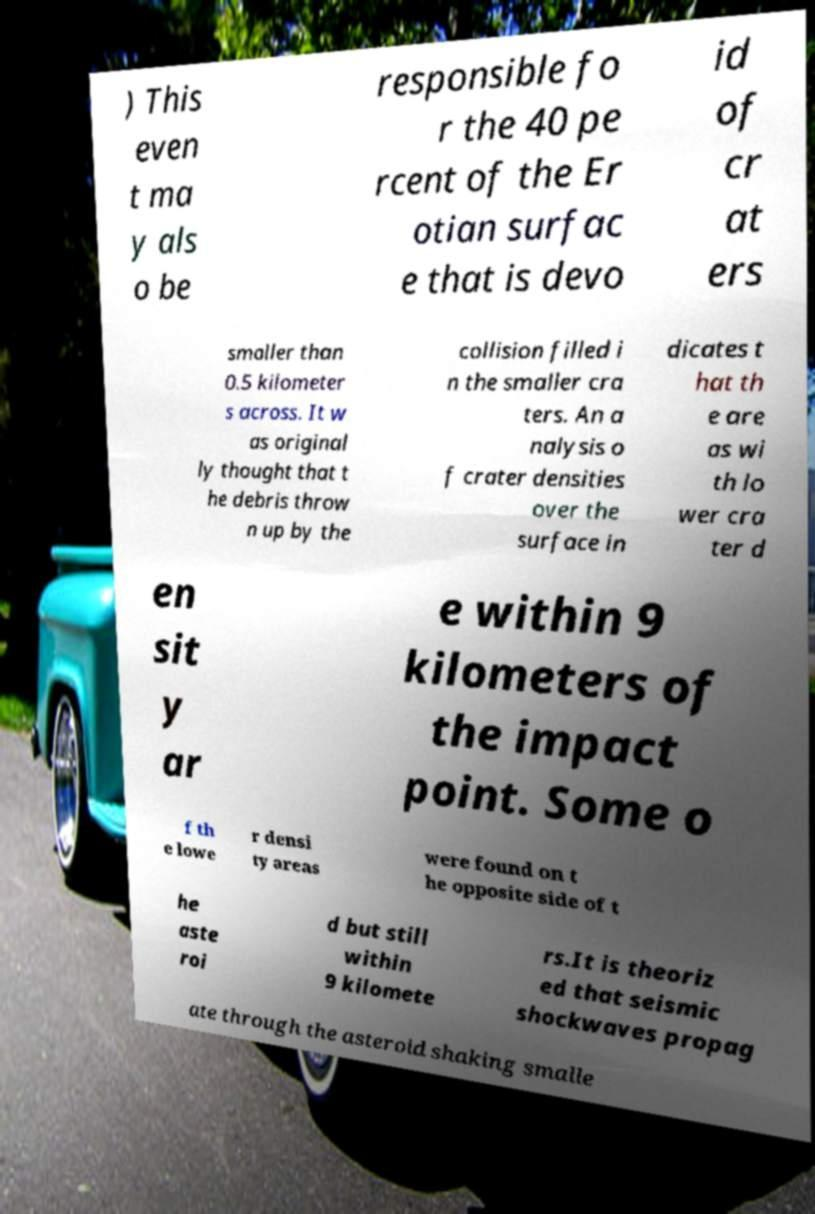Could you extract and type out the text from this image? ) This even t ma y als o be responsible fo r the 40 pe rcent of the Er otian surfac e that is devo id of cr at ers smaller than 0.5 kilometer s across. It w as original ly thought that t he debris throw n up by the collision filled i n the smaller cra ters. An a nalysis o f crater densities over the surface in dicates t hat th e are as wi th lo wer cra ter d en sit y ar e within 9 kilometers of the impact point. Some o f th e lowe r densi ty areas were found on t he opposite side of t he aste roi d but still within 9 kilomete rs.It is theoriz ed that seismic shockwaves propag ate through the asteroid shaking smalle 